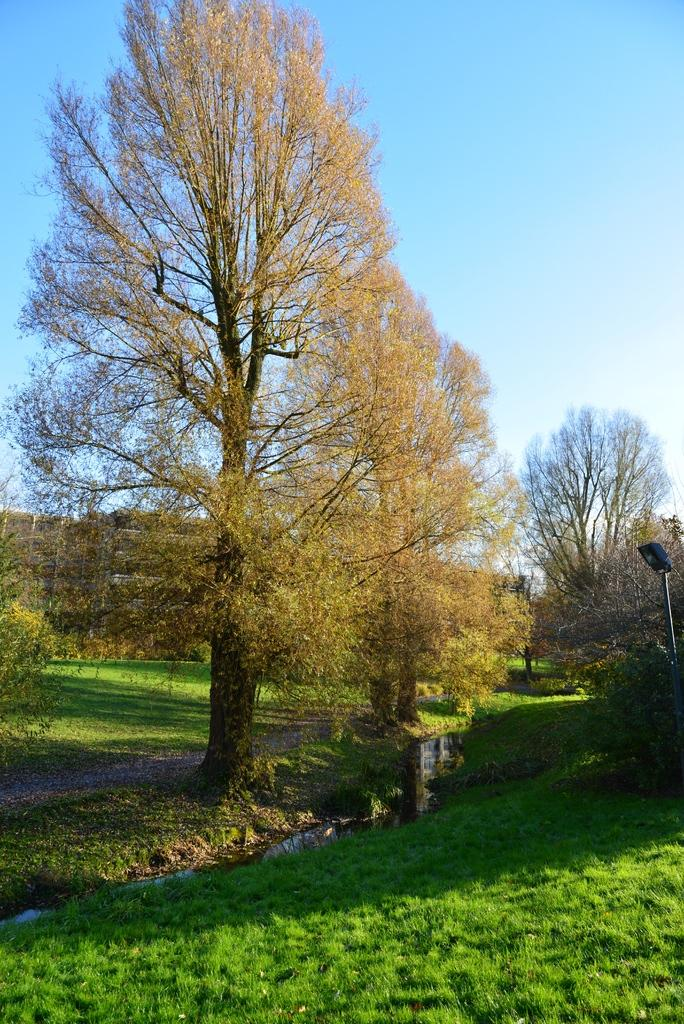What type of ground covering is visible in the image? The ground in the image is covered with grass. What can be seen in the distance in the image? There are many trees visible in the background. What type of structure is present in the image? There is a street light pole in the image. What is the condition of the sky in the image? The sky is clear in the image. What type of jeans is the tree wearing in the image? There are no jeans present in the image, as trees do not wear clothing. 